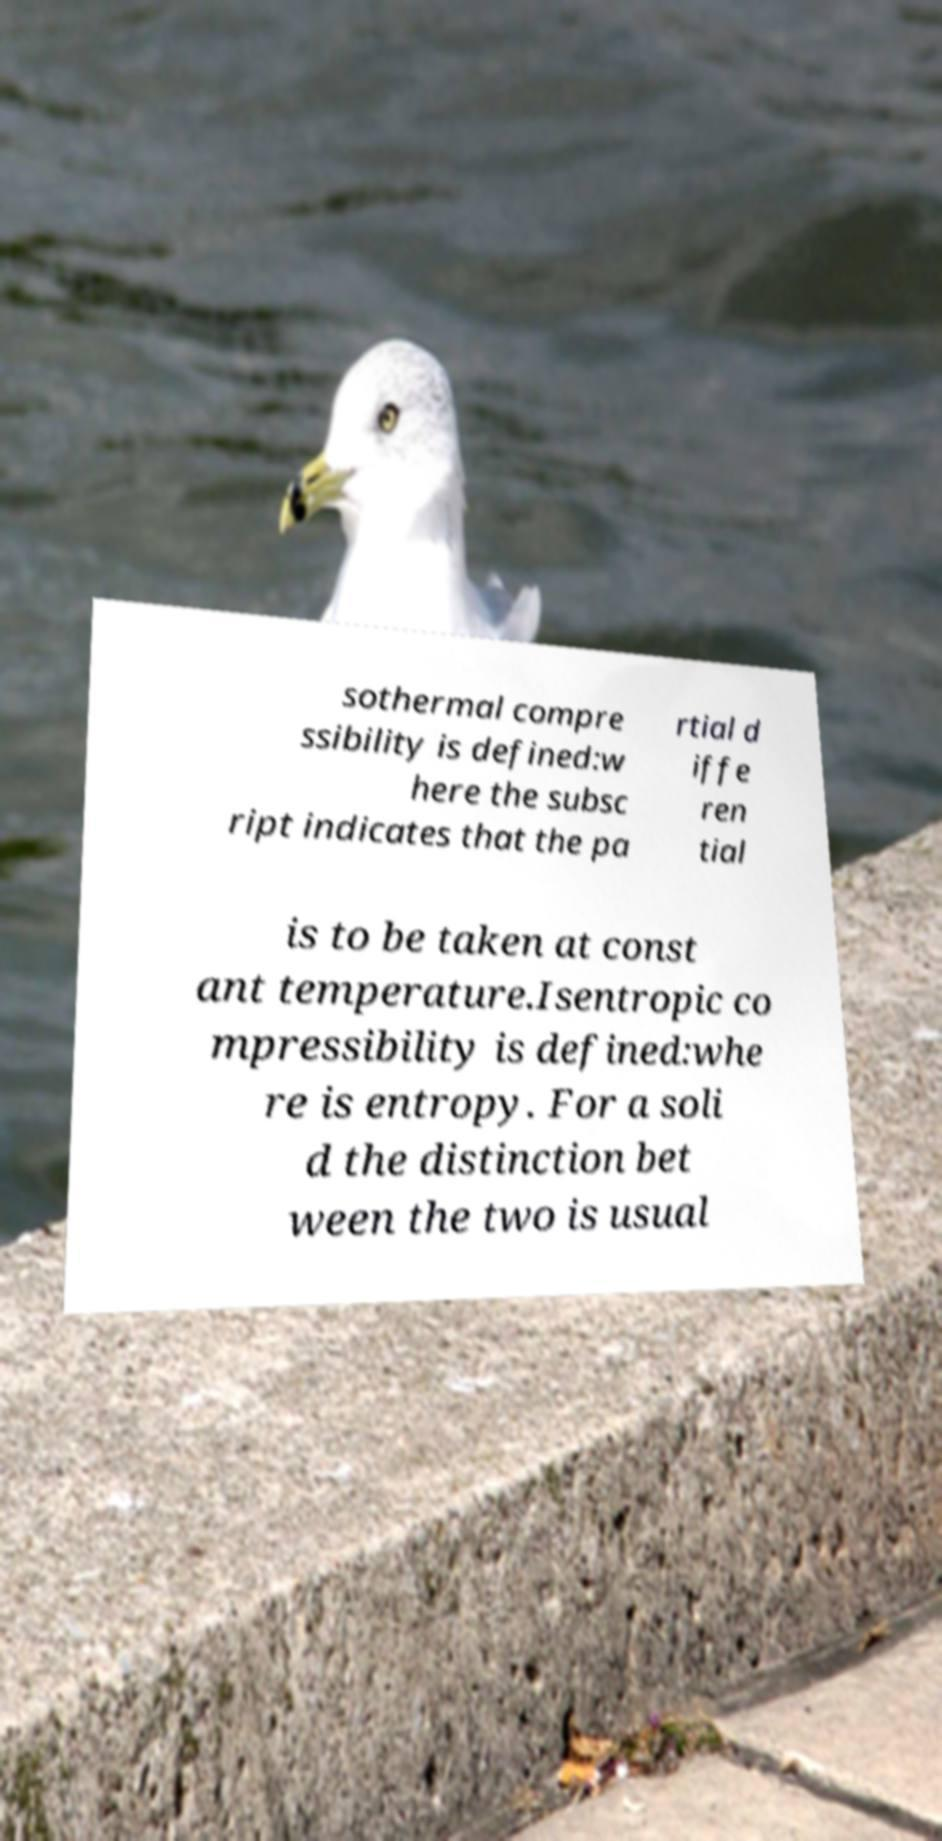Please identify and transcribe the text found in this image. sothermal compre ssibility is defined:w here the subsc ript indicates that the pa rtial d iffe ren tial is to be taken at const ant temperature.Isentropic co mpressibility is defined:whe re is entropy. For a soli d the distinction bet ween the two is usual 